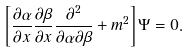Convert formula to latex. <formula><loc_0><loc_0><loc_500><loc_500>\left [ \frac { \partial \alpha } { \partial x } \frac { \partial \beta } { \partial x } \frac { \partial ^ { 2 } } { \partial \alpha \partial \beta } + m ^ { 2 } \right ] \Psi = 0 .</formula> 